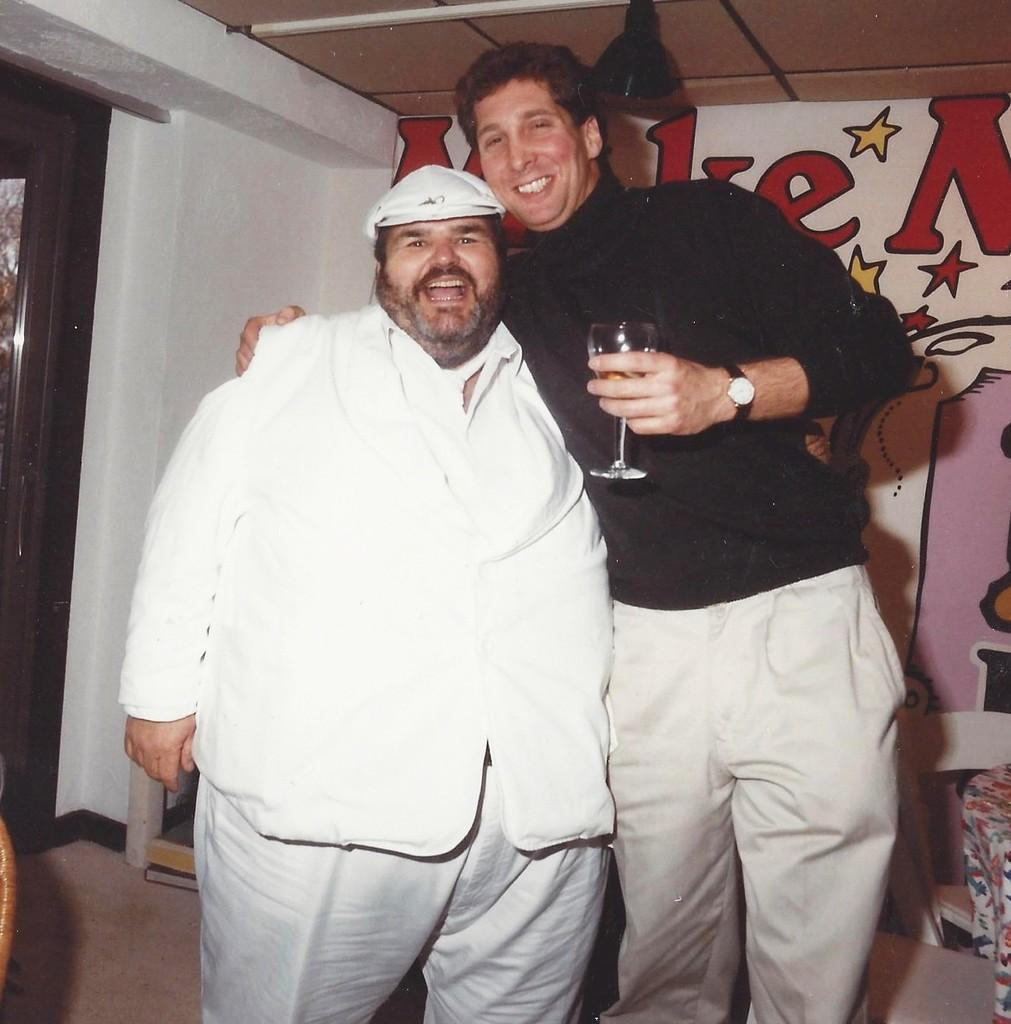How many people are present in the image? There are two men standing in the image. What is one of the men holding in his hand? One of the men is holding a wine glass in his hand. What can be seen on the wall in the background? There is a poster on the wall in the background. What type of yoke is being used by the men in the image? There is no yoke present in the image. Can you tell me what request the men are making in the image? There is no indication of a request being made in the image. 